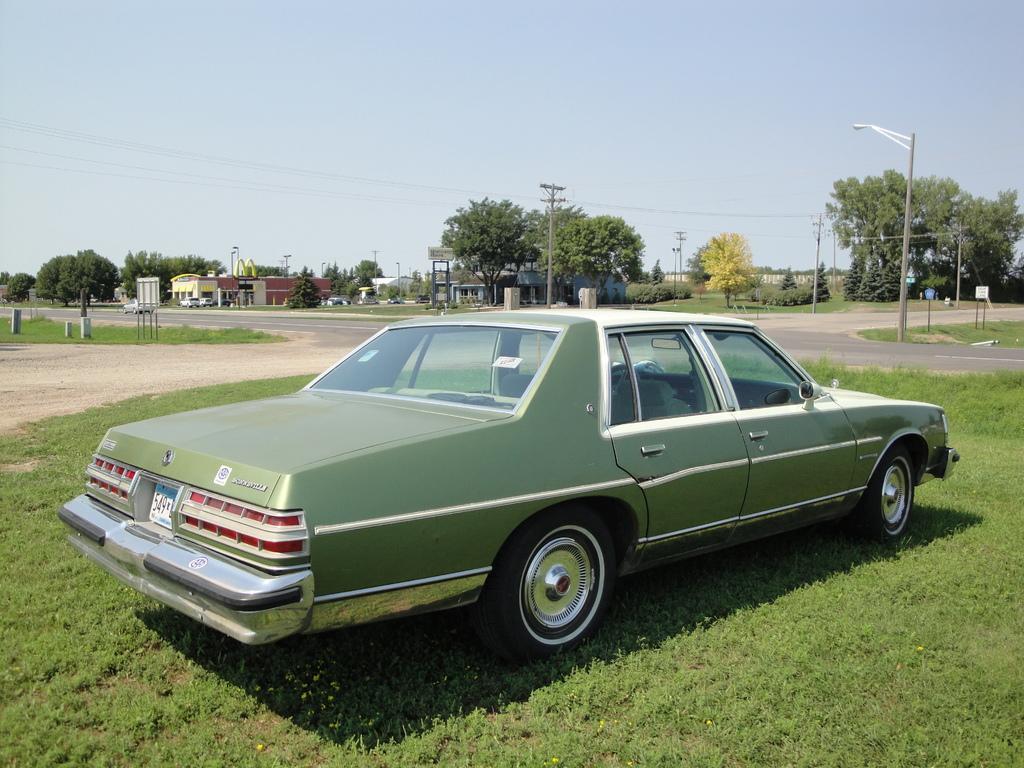Could you give a brief overview of what you see in this image? In this image we can see there is a car parked on the surface of the grass. In the background there are buildings, utility poles, trees and sky. 